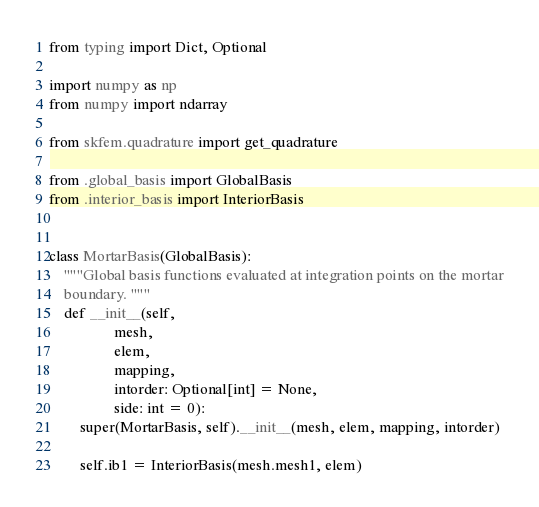Convert code to text. <code><loc_0><loc_0><loc_500><loc_500><_Python_>from typing import Dict, Optional

import numpy as np
from numpy import ndarray

from skfem.quadrature import get_quadrature

from .global_basis import GlobalBasis
from .interior_basis import InteriorBasis


class MortarBasis(GlobalBasis):
    """Global basis functions evaluated at integration points on the mortar
    boundary. """
    def __init__(self,
                 mesh,
                 elem,
                 mapping,
                 intorder: Optional[int] = None,
                 side: int = 0):
        super(MortarBasis, self).__init__(mesh, elem, mapping, intorder)

        self.ib1 = InteriorBasis(mesh.mesh1, elem)</code> 